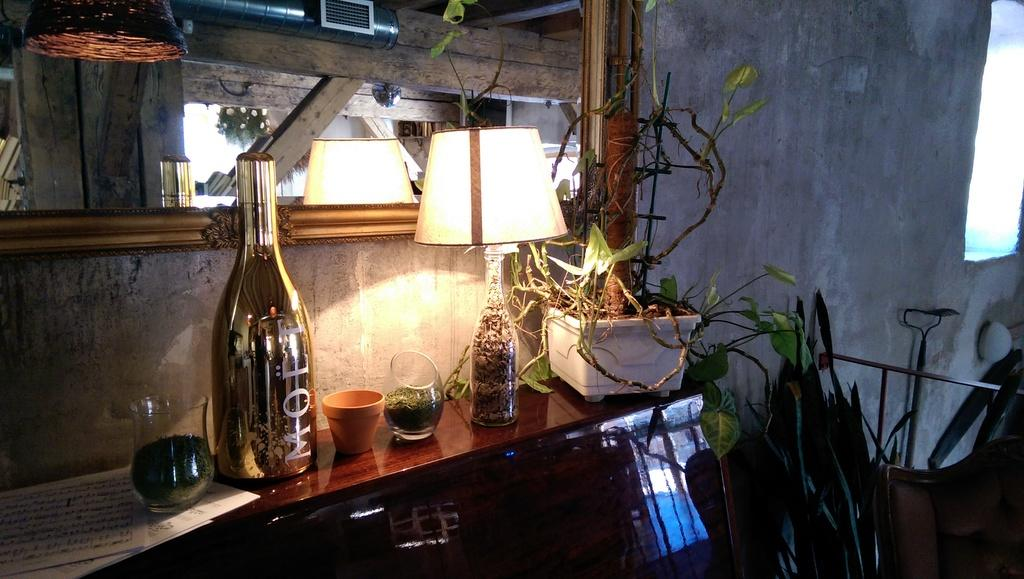What type of lighting is present on the table in the image? There is a lantern lamp on the table in the image. What other objects can be seen on the table? There is a pot, a jar, a bottle, and a plant on the table. What might be used for holding liquids in the image? The jar and bottle on the table can be used for holding liquids. What type of plant is on the table? The specific type of plant cannot be determined from the image. What type of marble is visible on the table in the image? There is no marble present on the table in the image. What type of clouds can be seen through the window in the image? There is no window or clouds visible in the image. 